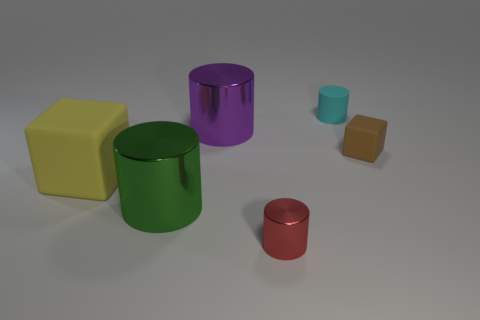How many other things are there of the same material as the big purple object?
Provide a succinct answer. 2. What is the material of the small brown thing?
Your answer should be compact. Rubber. How many big things are either brown metallic blocks or red metal cylinders?
Provide a short and direct response. 0. What number of large yellow things are in front of the tiny red cylinder?
Your answer should be very brief. 0. There is a purple thing that is the same size as the yellow matte cube; what is its shape?
Your answer should be compact. Cylinder. How many red things are matte objects or small things?
Provide a succinct answer. 1. What number of red shiny spheres are the same size as the green thing?
Offer a terse response. 0. What number of things are either big yellow things or tiny objects that are behind the tiny red cylinder?
Keep it short and to the point. 3. There is a block to the left of the cyan matte cylinder; is its size the same as the metal thing that is left of the purple metallic thing?
Offer a terse response. Yes. What number of other large yellow things have the same shape as the yellow rubber object?
Offer a very short reply. 0. 